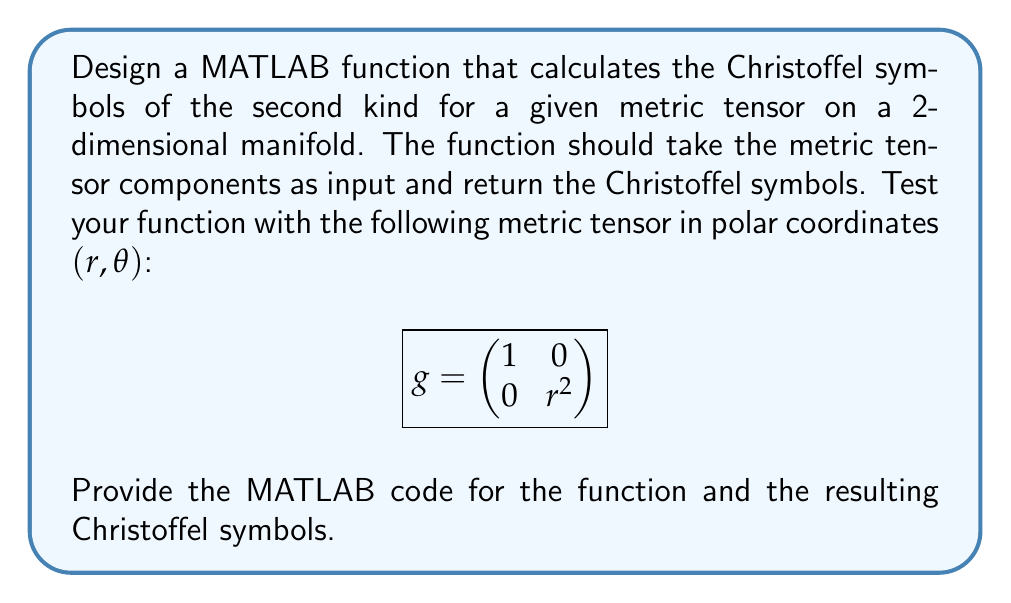Show me your answer to this math problem. To solve this problem, we need to follow these steps:

1. Define the MATLAB function to calculate Christoffel symbols.
2. Implement the formula for Christoffel symbols of the second kind:

   $$\Gamma^k_{ij} = \frac{1}{2}g^{kl}\left(\frac{\partial g_{jl}}{\partial x^i} + \frac{\partial g_{il}}{\partial x^j} - \frac{\partial g_{ij}}{\partial x^l}\right)$$

3. Calculate the inverse metric tensor $g^{ij}$.
4. Compute the partial derivatives of the metric tensor components.
5. Apply the formula to calculate all Christoffel symbols.
6. Test the function with the given metric tensor.

Here's the MATLAB function to calculate Christoffel symbols:

```matlab
function Gamma = christoffel_symbols(g, x)
    % g: metric tensor (symbolic matrix)
    % x: coordinate variables (symbolic vector)
    
    n = size(g, 1); % dimension of the manifold
    Gamma = sym(zeros(n, n, n));
    
    % Calculate inverse metric tensor
    g_inv = inv(g);
    
    % Calculate Christoffel symbols
    for k = 1:n
        for i = 1:n
            for j = 1:n
                sum = 0;
                for l = 1:n
                    sum = sum + 1/2 * g_inv(k,l) * ...
                          (diff(g(j,l), x(i)) + diff(g(i,l), x(j)) - diff(g(i,j), x(l)));
                end
                Gamma(k,i,j) = sum;
            end
        end
    end
end
```

To test the function with the given metric tensor:

```matlab
syms r theta
x = [r; theta];
g = [1 0; 0 r^2];

Gamma = christoffel_symbols(g, x);

% Display results
for k = 1:2
    for i = 1:2
        for j = 1:2
            fprintf('Gamma^%d_%d%d = %s\n', k, i, j, char(simplify(Gamma(k,i,j))));
        end
    end
end
```

This code will calculate and display all Christoffel symbols for the given metric tensor.
Answer: The Christoffel symbols for the given metric tensor in polar coordinates $(r,\theta)$ are:

$$\Gamma^1_{11} = 0$$
$$\Gamma^1_{12} = \Gamma^1_{21} = 0$$
$$\Gamma^1_{22} = -r$$
$$\Gamma^2_{11} = 0$$
$$\Gamma^2_{12} = \Gamma^2_{21} = \frac{1}{r}$$
$$\Gamma^2_{22} = 0$$

These results can be obtained by running the MATLAB function with the given metric tensor. 